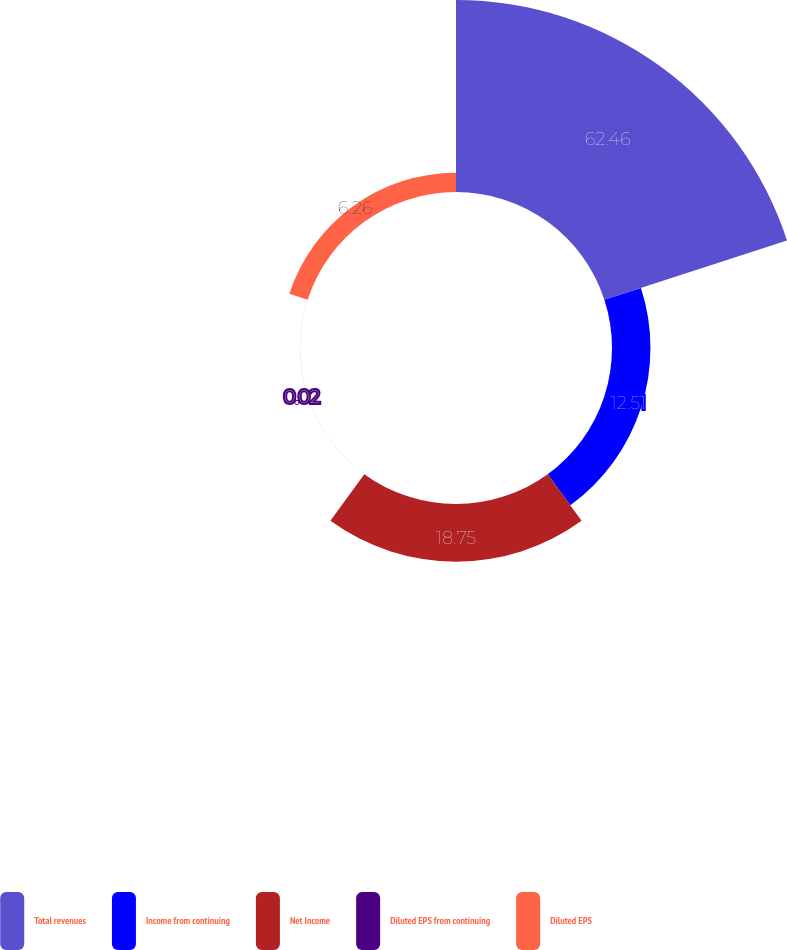<chart> <loc_0><loc_0><loc_500><loc_500><pie_chart><fcel>Total revenues<fcel>Income from continuing<fcel>Net Income<fcel>Diluted EPS from continuing<fcel>Diluted EPS<nl><fcel>62.46%<fcel>12.51%<fcel>18.75%<fcel>0.02%<fcel>6.26%<nl></chart> 